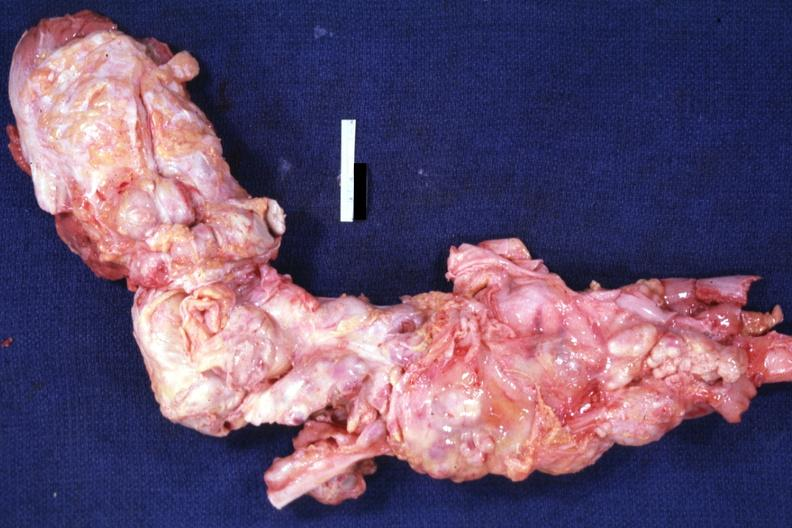what is aorta not opened?
Answer the question using a single word or phrase. Surrounded by large nodes 